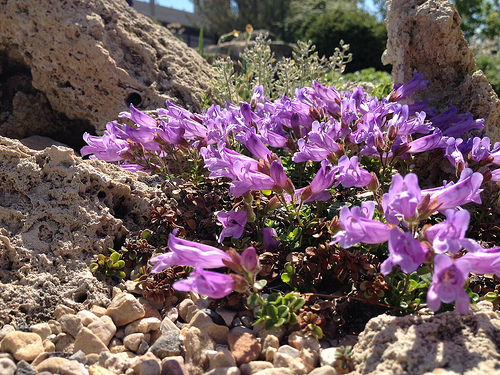<image>
Can you confirm if the flower is behind the tree? Yes. From this viewpoint, the flower is positioned behind the tree, with the tree partially or fully occluding the flower. Is there a pebble to the left of the flower? Yes. From this viewpoint, the pebble is positioned to the left side relative to the flower. 